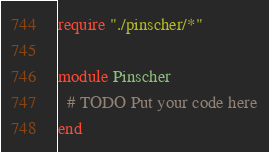Convert code to text. <code><loc_0><loc_0><loc_500><loc_500><_Crystal_>require "./pinscher/*"

module Pinscher
  # TODO Put your code here
end
</code> 